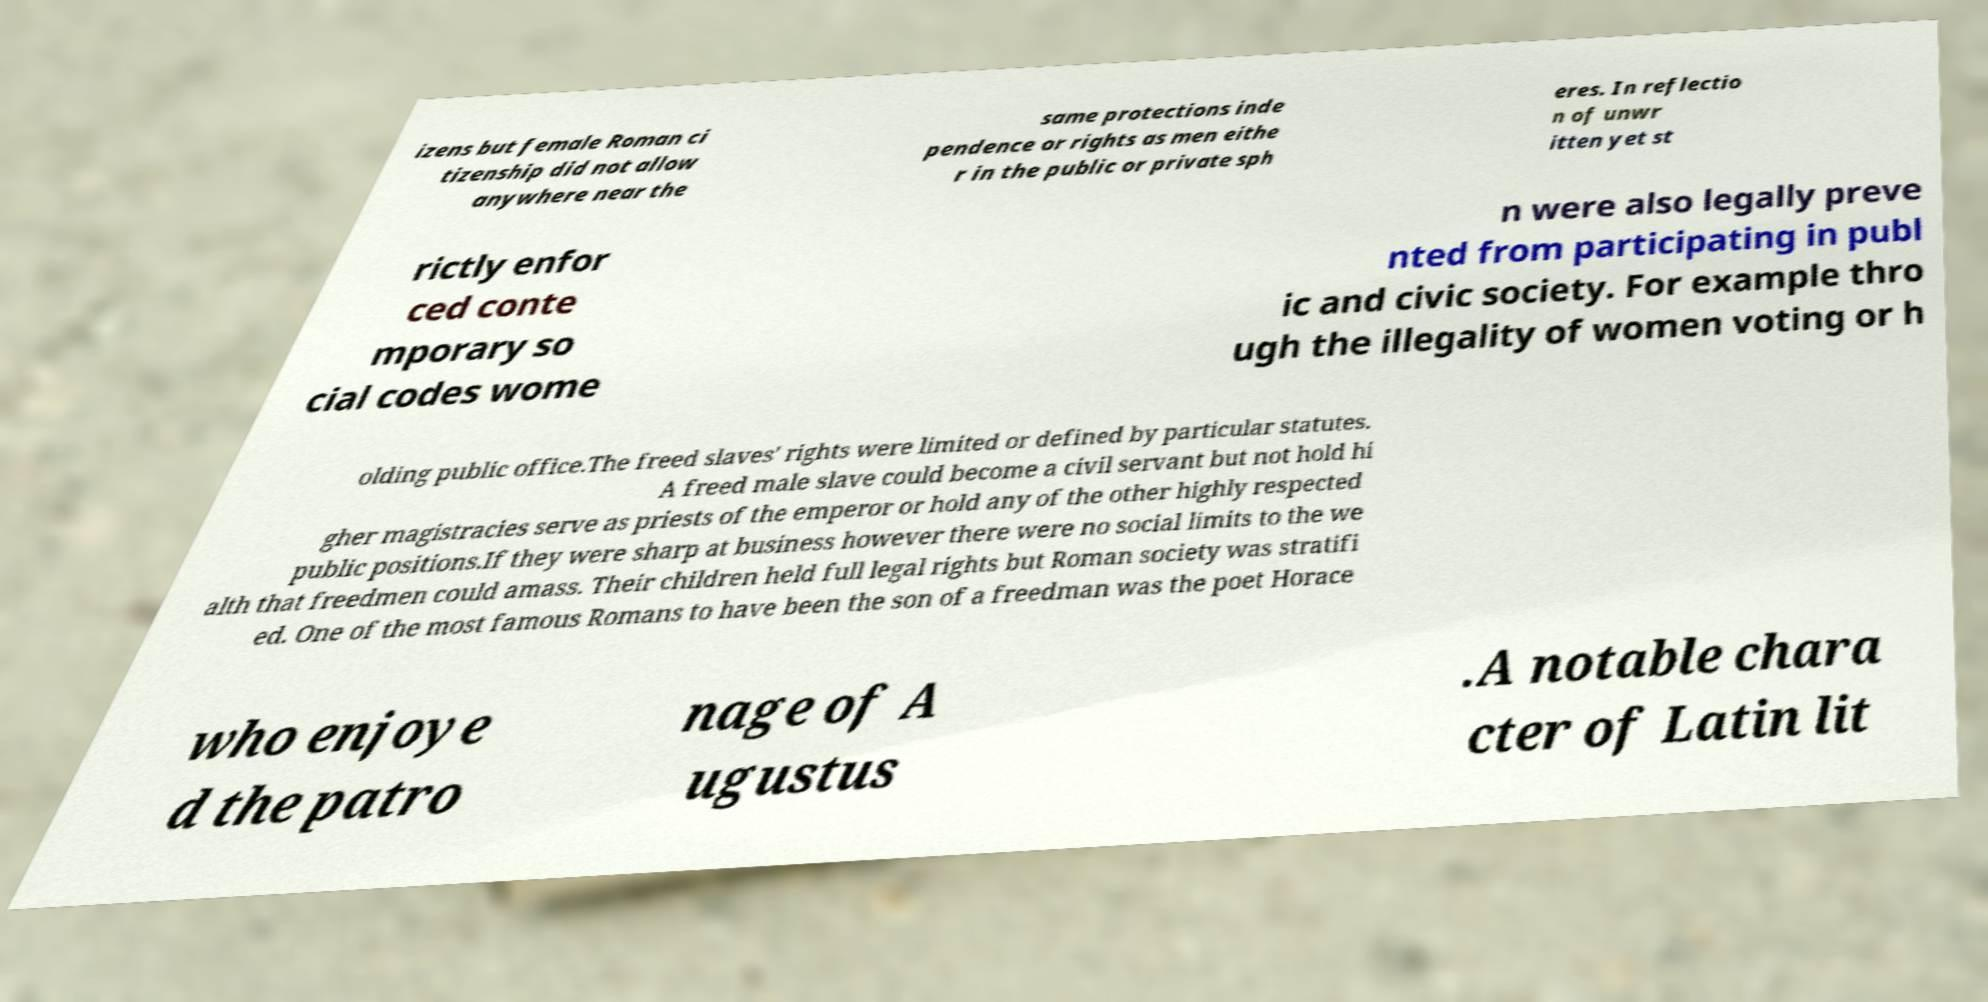Can you read and provide the text displayed in the image?This photo seems to have some interesting text. Can you extract and type it out for me? izens but female Roman ci tizenship did not allow anywhere near the same protections inde pendence or rights as men eithe r in the public or private sph eres. In reflectio n of unwr itten yet st rictly enfor ced conte mporary so cial codes wome n were also legally preve nted from participating in publ ic and civic society. For example thro ugh the illegality of women voting or h olding public office.The freed slaves' rights were limited or defined by particular statutes. A freed male slave could become a civil servant but not hold hi gher magistracies serve as priests of the emperor or hold any of the other highly respected public positions.If they were sharp at business however there were no social limits to the we alth that freedmen could amass. Their children held full legal rights but Roman society was stratifi ed. One of the most famous Romans to have been the son of a freedman was the poet Horace who enjoye d the patro nage of A ugustus .A notable chara cter of Latin lit 